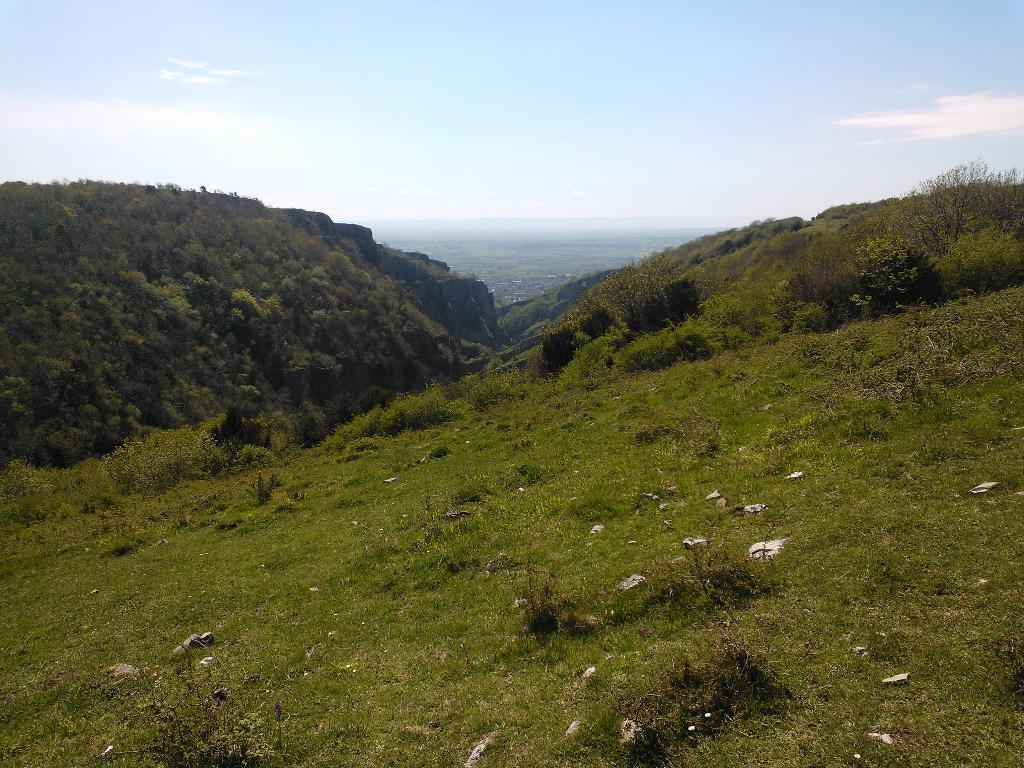What type of vegetation can be seen in the image? There is grass, plants, and trees in the image. What part of the natural environment is visible in the image? The sky is visible in the image. What type of string is being used to support the health of the berries in the image? There are no berries or strings present in the image. 